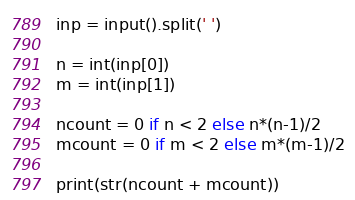<code> <loc_0><loc_0><loc_500><loc_500><_Python_>inp = input().split(' ')

n = int(inp[0])
m = int(inp[1])

ncount = 0 if n < 2 else n*(n-1)/2
mcount = 0 if m < 2 else m*(m-1)/2

print(str(ncount + mcount))</code> 